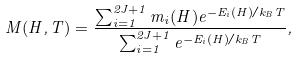<formula> <loc_0><loc_0><loc_500><loc_500>M ( H , T ) = \frac { \sum _ { i = 1 } ^ { 2 J + 1 } m _ { i } ( H ) e ^ { - E _ { i } ( H ) / k _ { B } T } } { \sum _ { i = 1 } ^ { 2 J + 1 } e ^ { - E _ { i } ( H ) / k _ { B } T } } ,</formula> 